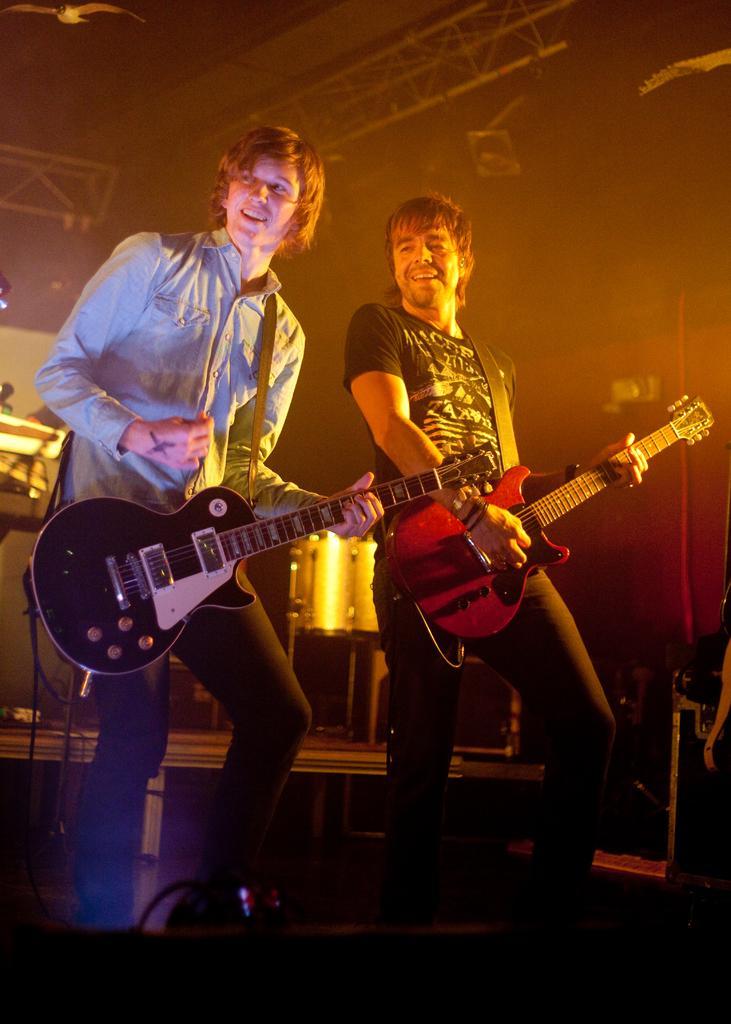Could you give a brief overview of what you see in this image? There are two people standing and playing guitar. At background I can see drum. This looks like a stage show. 